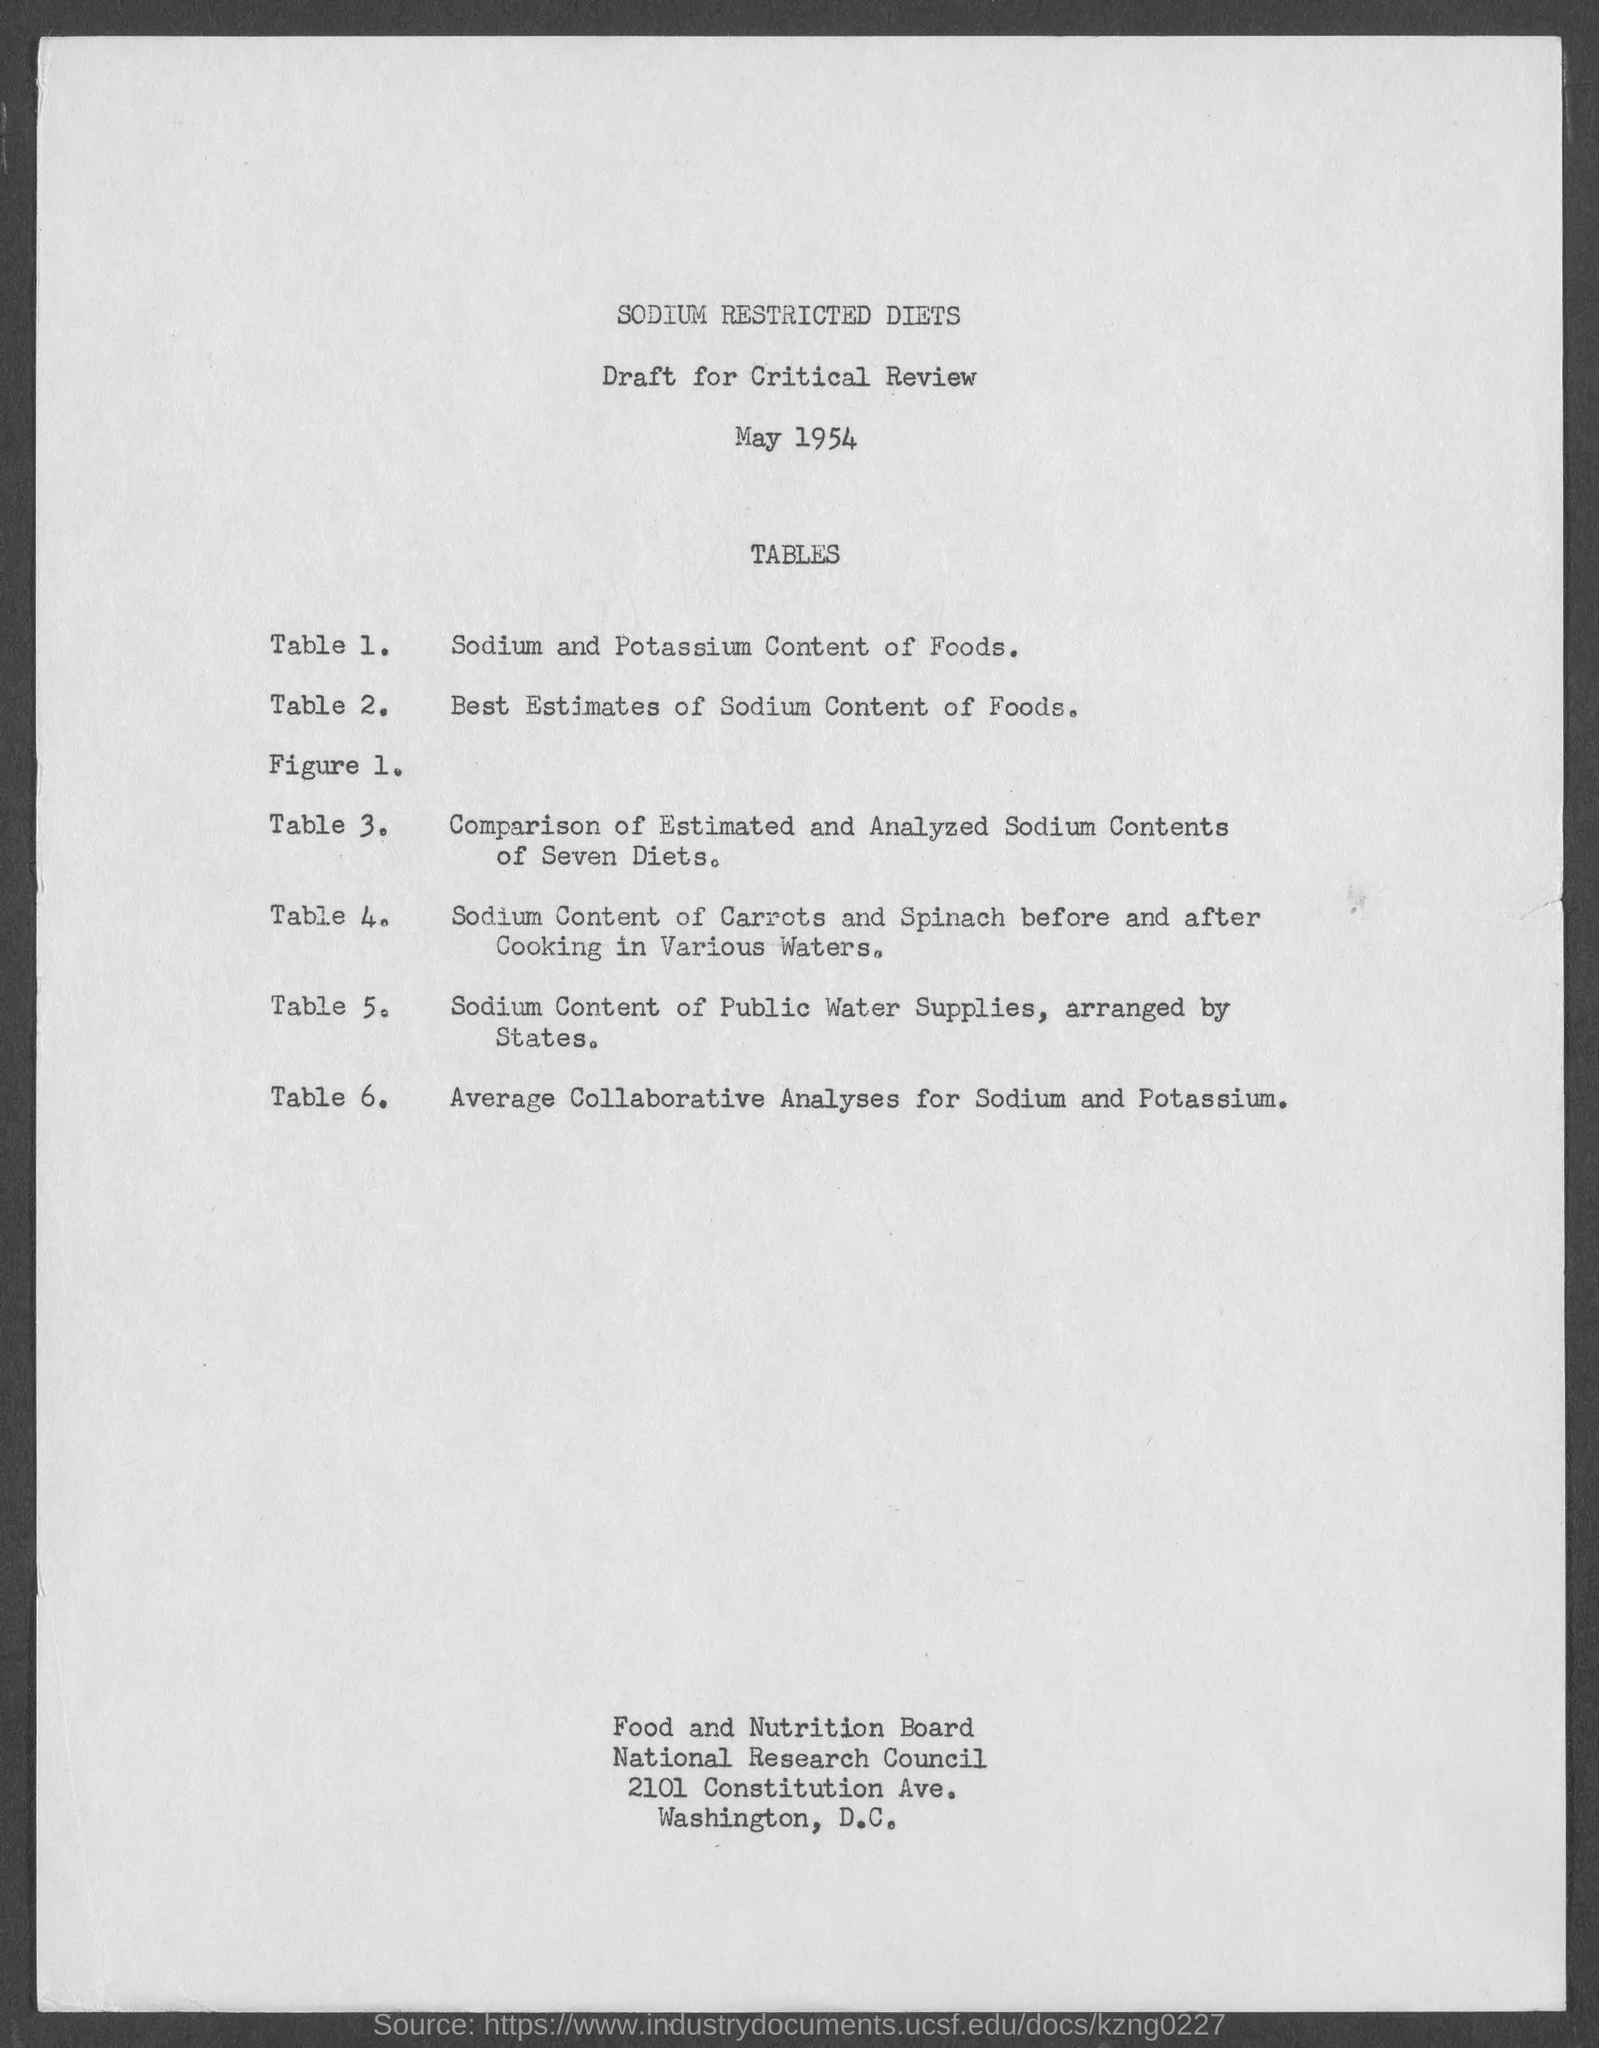Give some essential details in this illustration. The title of Table 6 is "Average Collaborative Analyses for Sodium and Potassium. The title of Table 1 is 'Sodium and Potassium Content of Foods.' The title of the document is 'Sodium Restricted Diets'. The title of Table 2 is 'Best Estimates of Sodium Content of Foods.' The street address of the Food and Nutrition Board is 2101 Constitution Ave. 